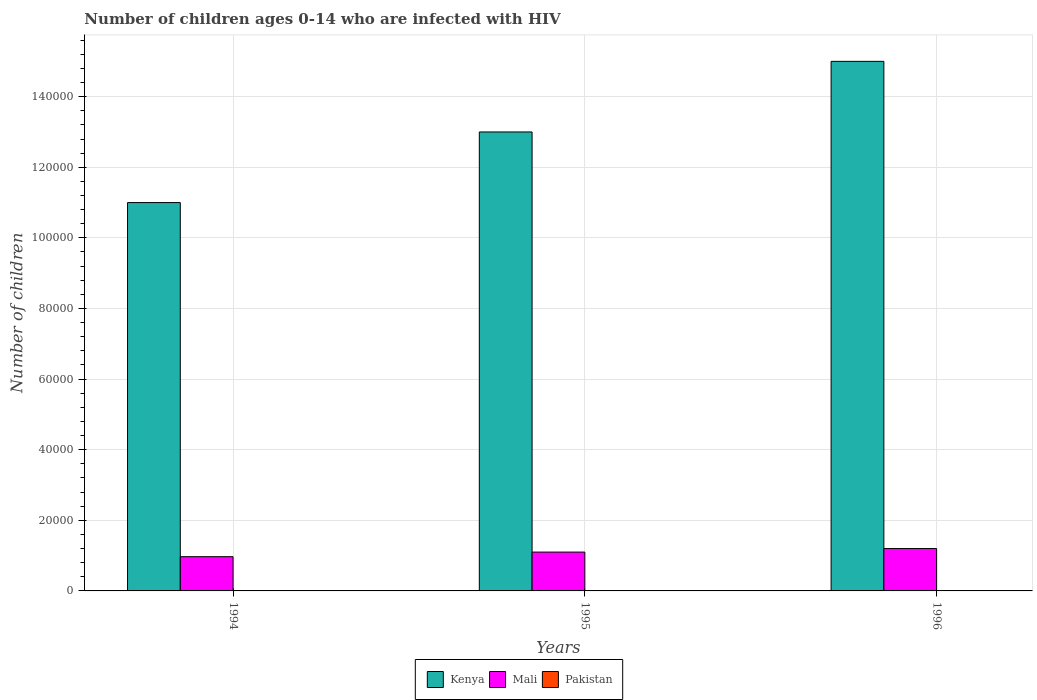How many groups of bars are there?
Offer a terse response. 3. Are the number of bars per tick equal to the number of legend labels?
Keep it short and to the point. Yes. How many bars are there on the 3rd tick from the left?
Provide a short and direct response. 3. What is the label of the 3rd group of bars from the left?
Provide a short and direct response. 1996. What is the number of HIV infected children in Pakistan in 1994?
Give a very brief answer. 100. Across all years, what is the maximum number of HIV infected children in Kenya?
Provide a succinct answer. 1.50e+05. Across all years, what is the minimum number of HIV infected children in Pakistan?
Ensure brevity in your answer.  100. In which year was the number of HIV infected children in Pakistan minimum?
Your answer should be compact. 1994. What is the total number of HIV infected children in Pakistan in the graph?
Your answer should be very brief. 300. What is the difference between the number of HIV infected children in Kenya in 1994 and that in 1996?
Make the answer very short. -4.00e+04. What is the difference between the number of HIV infected children in Kenya in 1996 and the number of HIV infected children in Mali in 1994?
Offer a terse response. 1.40e+05. What is the average number of HIV infected children in Kenya per year?
Provide a short and direct response. 1.30e+05. In the year 1994, what is the difference between the number of HIV infected children in Mali and number of HIV infected children in Kenya?
Your answer should be compact. -1.00e+05. In how many years, is the number of HIV infected children in Pakistan greater than 100000?
Your response must be concise. 0. What is the ratio of the number of HIV infected children in Pakistan in 1994 to that in 1996?
Offer a terse response. 1. Is the difference between the number of HIV infected children in Mali in 1994 and 1995 greater than the difference between the number of HIV infected children in Kenya in 1994 and 1995?
Offer a very short reply. Yes. What is the difference between the highest and the lowest number of HIV infected children in Pakistan?
Ensure brevity in your answer.  0. Is the sum of the number of HIV infected children in Mali in 1994 and 1996 greater than the maximum number of HIV infected children in Pakistan across all years?
Ensure brevity in your answer.  Yes. What does the 2nd bar from the left in 1994 represents?
Keep it short and to the point. Mali. What does the 3rd bar from the right in 1994 represents?
Keep it short and to the point. Kenya. Are all the bars in the graph horizontal?
Offer a terse response. No. How many years are there in the graph?
Make the answer very short. 3. What is the difference between two consecutive major ticks on the Y-axis?
Ensure brevity in your answer.  2.00e+04. Does the graph contain any zero values?
Ensure brevity in your answer.  No. Where does the legend appear in the graph?
Your answer should be compact. Bottom center. How many legend labels are there?
Provide a short and direct response. 3. How are the legend labels stacked?
Offer a very short reply. Horizontal. What is the title of the graph?
Offer a very short reply. Number of children ages 0-14 who are infected with HIV. Does "Romania" appear as one of the legend labels in the graph?
Ensure brevity in your answer.  No. What is the label or title of the Y-axis?
Your response must be concise. Number of children. What is the Number of children of Kenya in 1994?
Your answer should be compact. 1.10e+05. What is the Number of children of Mali in 1994?
Ensure brevity in your answer.  9700. What is the Number of children of Kenya in 1995?
Your answer should be very brief. 1.30e+05. What is the Number of children in Mali in 1995?
Make the answer very short. 1.10e+04. What is the Number of children in Pakistan in 1995?
Ensure brevity in your answer.  100. What is the Number of children of Mali in 1996?
Provide a succinct answer. 1.20e+04. What is the Number of children of Pakistan in 1996?
Ensure brevity in your answer.  100. Across all years, what is the maximum Number of children of Kenya?
Ensure brevity in your answer.  1.50e+05. Across all years, what is the maximum Number of children in Mali?
Provide a short and direct response. 1.20e+04. Across all years, what is the maximum Number of children of Pakistan?
Your response must be concise. 100. Across all years, what is the minimum Number of children in Kenya?
Your answer should be compact. 1.10e+05. Across all years, what is the minimum Number of children of Mali?
Keep it short and to the point. 9700. What is the total Number of children in Mali in the graph?
Provide a succinct answer. 3.27e+04. What is the total Number of children of Pakistan in the graph?
Provide a short and direct response. 300. What is the difference between the Number of children in Mali in 1994 and that in 1995?
Your response must be concise. -1300. What is the difference between the Number of children of Kenya in 1994 and that in 1996?
Your answer should be very brief. -4.00e+04. What is the difference between the Number of children in Mali in 1994 and that in 1996?
Provide a succinct answer. -2300. What is the difference between the Number of children of Kenya in 1995 and that in 1996?
Provide a succinct answer. -2.00e+04. What is the difference between the Number of children in Mali in 1995 and that in 1996?
Provide a short and direct response. -1000. What is the difference between the Number of children in Pakistan in 1995 and that in 1996?
Make the answer very short. 0. What is the difference between the Number of children of Kenya in 1994 and the Number of children of Mali in 1995?
Ensure brevity in your answer.  9.90e+04. What is the difference between the Number of children of Kenya in 1994 and the Number of children of Pakistan in 1995?
Offer a terse response. 1.10e+05. What is the difference between the Number of children in Mali in 1994 and the Number of children in Pakistan in 1995?
Keep it short and to the point. 9600. What is the difference between the Number of children of Kenya in 1994 and the Number of children of Mali in 1996?
Your response must be concise. 9.80e+04. What is the difference between the Number of children in Kenya in 1994 and the Number of children in Pakistan in 1996?
Provide a succinct answer. 1.10e+05. What is the difference between the Number of children of Mali in 1994 and the Number of children of Pakistan in 1996?
Your answer should be compact. 9600. What is the difference between the Number of children of Kenya in 1995 and the Number of children of Mali in 1996?
Offer a terse response. 1.18e+05. What is the difference between the Number of children in Kenya in 1995 and the Number of children in Pakistan in 1996?
Provide a short and direct response. 1.30e+05. What is the difference between the Number of children of Mali in 1995 and the Number of children of Pakistan in 1996?
Provide a succinct answer. 1.09e+04. What is the average Number of children in Kenya per year?
Your answer should be very brief. 1.30e+05. What is the average Number of children of Mali per year?
Your response must be concise. 1.09e+04. In the year 1994, what is the difference between the Number of children in Kenya and Number of children in Mali?
Give a very brief answer. 1.00e+05. In the year 1994, what is the difference between the Number of children in Kenya and Number of children in Pakistan?
Your answer should be compact. 1.10e+05. In the year 1994, what is the difference between the Number of children of Mali and Number of children of Pakistan?
Provide a succinct answer. 9600. In the year 1995, what is the difference between the Number of children of Kenya and Number of children of Mali?
Give a very brief answer. 1.19e+05. In the year 1995, what is the difference between the Number of children in Kenya and Number of children in Pakistan?
Your response must be concise. 1.30e+05. In the year 1995, what is the difference between the Number of children of Mali and Number of children of Pakistan?
Provide a short and direct response. 1.09e+04. In the year 1996, what is the difference between the Number of children in Kenya and Number of children in Mali?
Ensure brevity in your answer.  1.38e+05. In the year 1996, what is the difference between the Number of children of Kenya and Number of children of Pakistan?
Make the answer very short. 1.50e+05. In the year 1996, what is the difference between the Number of children of Mali and Number of children of Pakistan?
Ensure brevity in your answer.  1.19e+04. What is the ratio of the Number of children of Kenya in 1994 to that in 1995?
Ensure brevity in your answer.  0.85. What is the ratio of the Number of children in Mali in 1994 to that in 1995?
Ensure brevity in your answer.  0.88. What is the ratio of the Number of children in Kenya in 1994 to that in 1996?
Ensure brevity in your answer.  0.73. What is the ratio of the Number of children in Mali in 1994 to that in 1996?
Offer a very short reply. 0.81. What is the ratio of the Number of children in Kenya in 1995 to that in 1996?
Make the answer very short. 0.87. What is the ratio of the Number of children in Pakistan in 1995 to that in 1996?
Make the answer very short. 1. What is the difference between the highest and the second highest Number of children in Mali?
Provide a succinct answer. 1000. What is the difference between the highest and the second highest Number of children in Pakistan?
Your answer should be very brief. 0. What is the difference between the highest and the lowest Number of children in Kenya?
Ensure brevity in your answer.  4.00e+04. What is the difference between the highest and the lowest Number of children in Mali?
Provide a short and direct response. 2300. What is the difference between the highest and the lowest Number of children in Pakistan?
Offer a very short reply. 0. 